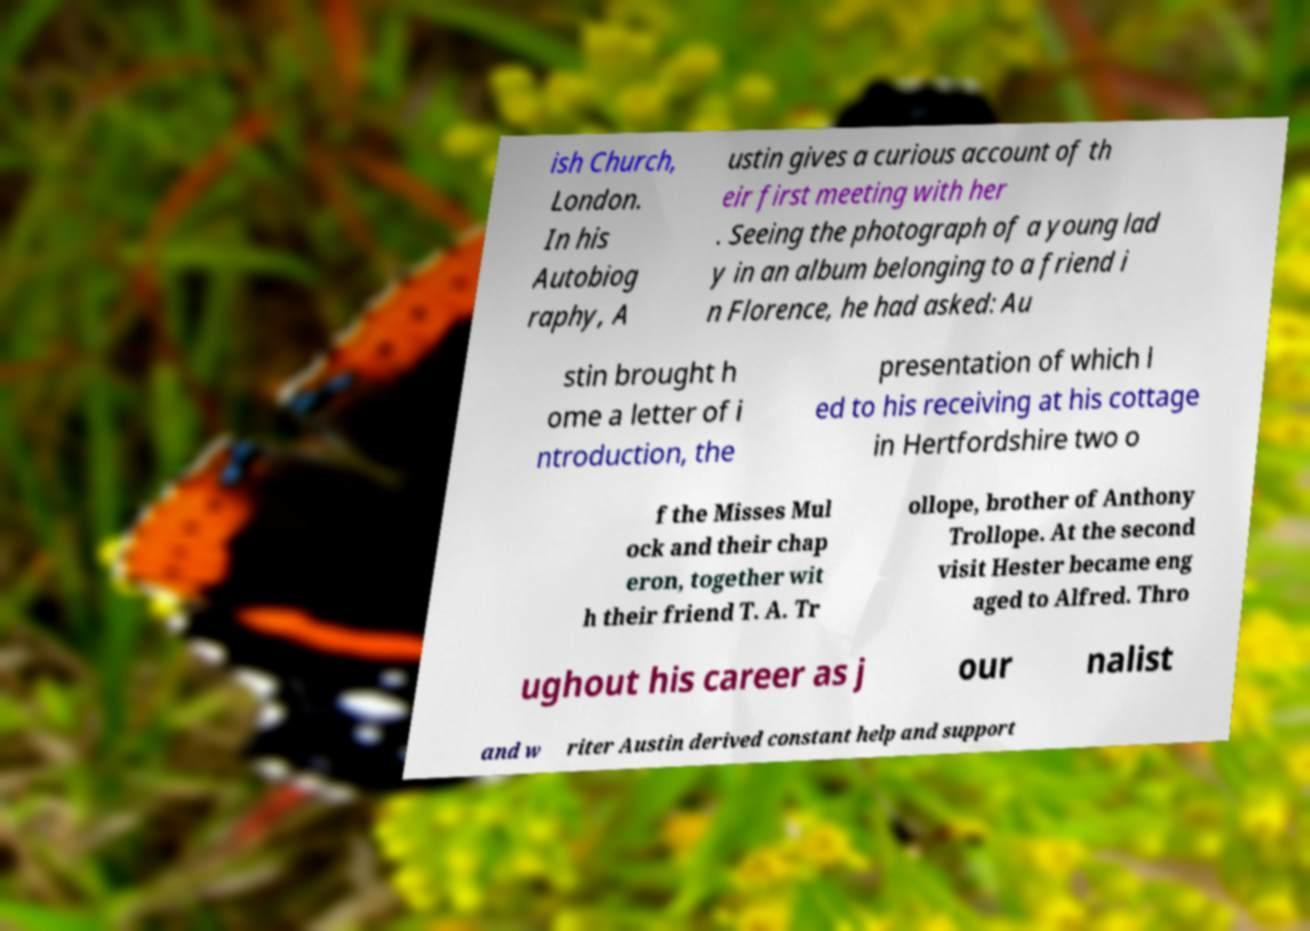What messages or text are displayed in this image? I need them in a readable, typed format. ish Church, London. In his Autobiog raphy, A ustin gives a curious account of th eir first meeting with her . Seeing the photograph of a young lad y in an album belonging to a friend i n Florence, he had asked: Au stin brought h ome a letter of i ntroduction, the presentation of which l ed to his receiving at his cottage in Hertfordshire two o f the Misses Mul ock and their chap eron, together wit h their friend T. A. Tr ollope, brother of Anthony Trollope. At the second visit Hester became eng aged to Alfred. Thro ughout his career as j our nalist and w riter Austin derived constant help and support 